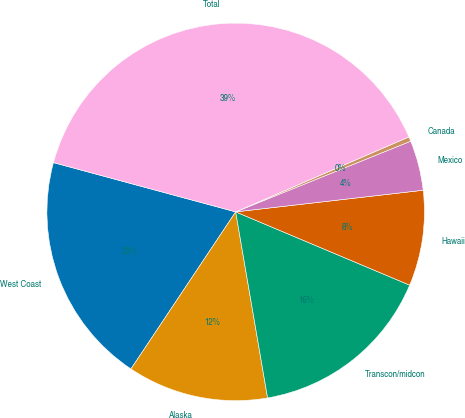Convert chart to OTSL. <chart><loc_0><loc_0><loc_500><loc_500><pie_chart><fcel>West Coast<fcel>Alaska<fcel>Transcon/midcon<fcel>Hawaii<fcel>Mexico<fcel>Canada<fcel>Total<nl><fcel>19.84%<fcel>12.06%<fcel>15.95%<fcel>8.17%<fcel>4.28%<fcel>0.39%<fcel>39.29%<nl></chart> 